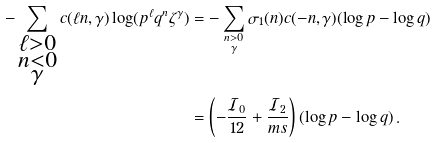Convert formula to latex. <formula><loc_0><loc_0><loc_500><loc_500>- \sum _ { \substack { \ell > 0 \\ n < 0 \\ \gamma } } c ( \ell n , \gamma ) \log ( p ^ { \ell } q ^ { n } \zeta ^ { \gamma } ) & = - \sum _ { \substack { n > 0 \\ \gamma } } \sigma _ { 1 } ( n ) c ( - n , \gamma ) ( \log p - \log q ) \\ & = \left ( - \frac { \mathcal { I } _ { 0 } } { 1 2 } + \frac { \mathcal { I } _ { 2 } } { m s } \right ) ( \log p - \log q ) \, .</formula> 